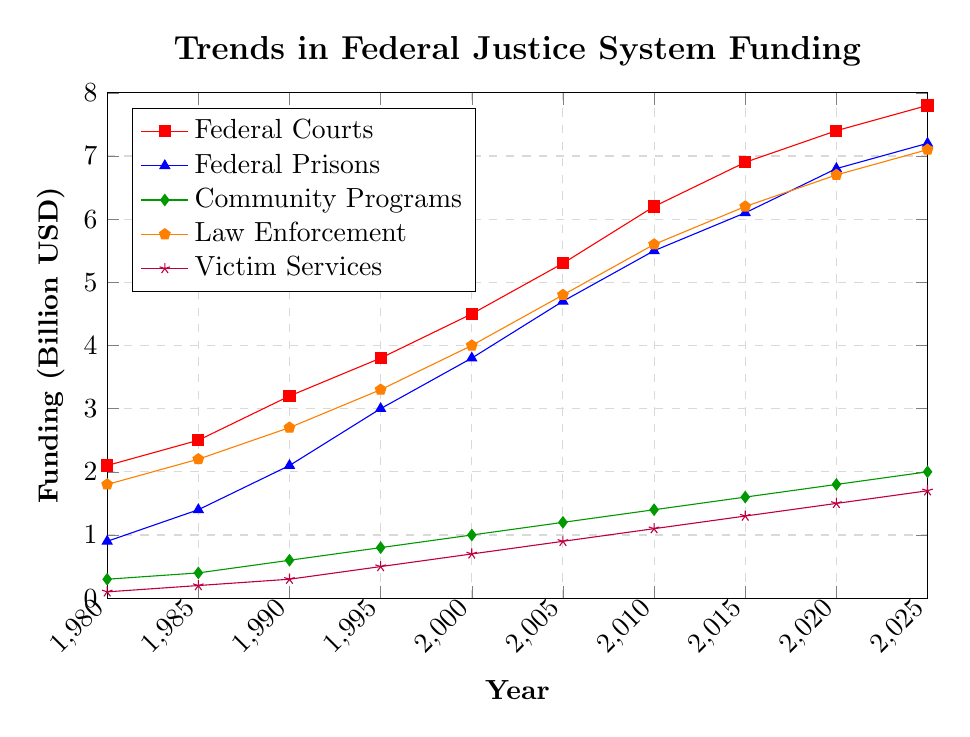What is the overall trend in federal funding for law enforcement from 1980 to 2025? The line for law enforcement funding on the chart shows a consistent upward trend from 1980, starting at 1.8 billion USD and rising to 7.1 billion USD by 2025.
Answer: Upward trend Which category of funding saw the highest increase over the given period? To determine this, we compare the initial and final values for each category: Federal Courts (2.1 to 7.8), Federal Prisons (0.9 to 7.2), Community Programs (0.3 to 2.0), Law Enforcement (1.8 to 7.1), Victim Services (0.1 to 1.7). The Federal Prisons category has the highest increase at 6.3 billion USD.
Answer: Federal Prisons How does the funding for community programs in 2025 compare to federal court funding in 1980? The chart shows that in 2025, community programs have 2.0 billion USD in funding, while in 1980, federal courts had 2.1 billion USD.
Answer: Slightly lower By how much did funding for victim services increase between 1990 and 2025? In 1990, funding for victim services was 0.3 billion USD, and it increased to 1.7 billion USD by 2025. The increase is 1.7 - 0.3 = 1.4 billion USD.
Answer: 1.4 billion USD Which funding category had the smallest increase from 1980 to 2025? We calculate the increase for each category: Federal Courts (5.7), Federal Prisons (6.3), Community Programs (1.7), Law Enforcement (5.3), Victim Services (1.6). Victim Services had the smallest increase, from 0.1 to 1.7 billion USD.
Answer: Victim Services In what year did federal courts funding surpass 5 billion USD? Looking at the chart, the funding for federal courts surpassed 5 billion USD between 2005 (5.3 billion USD) and 2010 (6.2 billion USD). Therefore, it happened in 2005.
Answer: 2005 Which color represents the category with the highest funding in 2025? The chart visually represents Federal Courts funding (7.8 billion USD in 2025) with a red line.
Answer: Red What is the total federal funding for all categories in 2020? Summing the values for each category in 2020: Federal Courts (7.4), Federal Prisons (6.8), Community Programs (1.8), Law Enforcement (6.7), Victim Services (1.5). Total is 7.4 + 6.8 + 1.8 + 6.7 + 1.5 = 24.2 billion USD.
Answer: 24.2 billion USD 